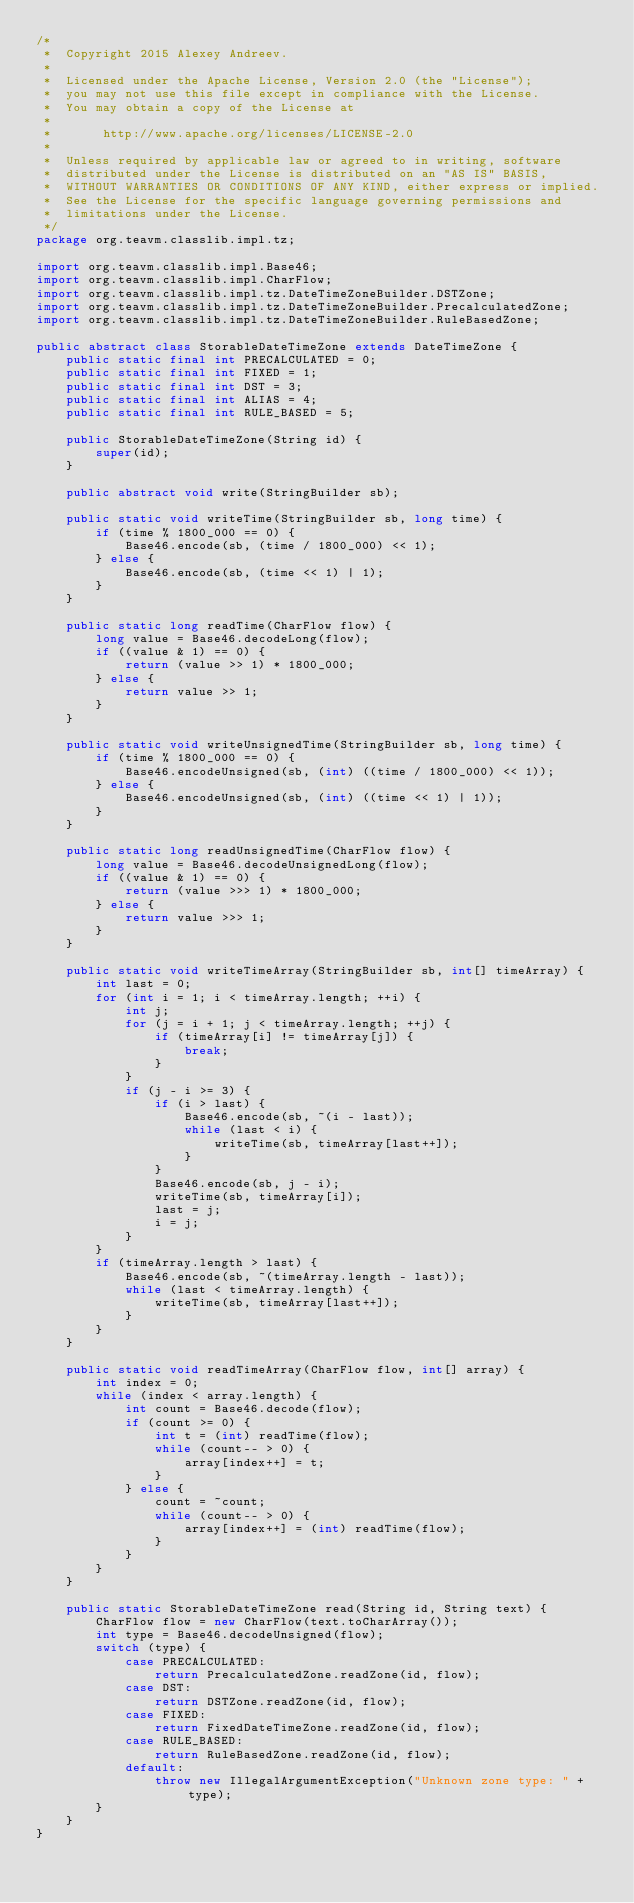<code> <loc_0><loc_0><loc_500><loc_500><_Java_>/*
 *  Copyright 2015 Alexey Andreev.
 *
 *  Licensed under the Apache License, Version 2.0 (the "License");
 *  you may not use this file except in compliance with the License.
 *  You may obtain a copy of the License at
 *
 *       http://www.apache.org/licenses/LICENSE-2.0
 *
 *  Unless required by applicable law or agreed to in writing, software
 *  distributed under the License is distributed on an "AS IS" BASIS,
 *  WITHOUT WARRANTIES OR CONDITIONS OF ANY KIND, either express or implied.
 *  See the License for the specific language governing permissions and
 *  limitations under the License.
 */
package org.teavm.classlib.impl.tz;

import org.teavm.classlib.impl.Base46;
import org.teavm.classlib.impl.CharFlow;
import org.teavm.classlib.impl.tz.DateTimeZoneBuilder.DSTZone;
import org.teavm.classlib.impl.tz.DateTimeZoneBuilder.PrecalculatedZone;
import org.teavm.classlib.impl.tz.DateTimeZoneBuilder.RuleBasedZone;

public abstract class StorableDateTimeZone extends DateTimeZone {
    public static final int PRECALCULATED = 0;
    public static final int FIXED = 1;
    public static final int DST = 3;
    public static final int ALIAS = 4;
    public static final int RULE_BASED = 5;

    public StorableDateTimeZone(String id) {
        super(id);
    }

    public abstract void write(StringBuilder sb);

    public static void writeTime(StringBuilder sb, long time) {
        if (time % 1800_000 == 0) {
            Base46.encode(sb, (time / 1800_000) << 1);
        } else {
            Base46.encode(sb, (time << 1) | 1);
        }
    }

    public static long readTime(CharFlow flow) {
        long value = Base46.decodeLong(flow);
        if ((value & 1) == 0) {
            return (value >> 1) * 1800_000;
        } else {
            return value >> 1;
        }
    }

    public static void writeUnsignedTime(StringBuilder sb, long time) {
        if (time % 1800_000 == 0) {
            Base46.encodeUnsigned(sb, (int) ((time / 1800_000) << 1));
        } else {
            Base46.encodeUnsigned(sb, (int) ((time << 1) | 1));
        }
    }

    public static long readUnsignedTime(CharFlow flow) {
        long value = Base46.decodeUnsignedLong(flow);
        if ((value & 1) == 0) {
            return (value >>> 1) * 1800_000;
        } else {
            return value >>> 1;
        }
    }

    public static void writeTimeArray(StringBuilder sb, int[] timeArray) {
        int last = 0;
        for (int i = 1; i < timeArray.length; ++i) {
            int j;
            for (j = i + 1; j < timeArray.length; ++j) {
                if (timeArray[i] != timeArray[j]) {
                    break;
                }
            }
            if (j - i >= 3) {
                if (i > last) {
                    Base46.encode(sb, ~(i - last));
                    while (last < i) {
                        writeTime(sb, timeArray[last++]);
                    }
                }
                Base46.encode(sb, j - i);
                writeTime(sb, timeArray[i]);
                last = j;
                i = j;
            }
        }
        if (timeArray.length > last) {
            Base46.encode(sb, ~(timeArray.length - last));
            while (last < timeArray.length) {
                writeTime(sb, timeArray[last++]);
            }
        }
    }

    public static void readTimeArray(CharFlow flow, int[] array) {
        int index = 0;
        while (index < array.length) {
            int count = Base46.decode(flow);
            if (count >= 0) {
                int t = (int) readTime(flow);
                while (count-- > 0) {
                    array[index++] = t;
                }
            } else {
                count = ~count;
                while (count-- > 0) {
                    array[index++] = (int) readTime(flow);
                }
            }
        }
    }

    public static StorableDateTimeZone read(String id, String text) {
        CharFlow flow = new CharFlow(text.toCharArray());
        int type = Base46.decodeUnsigned(flow);
        switch (type) {
            case PRECALCULATED:
                return PrecalculatedZone.readZone(id, flow);
            case DST:
                return DSTZone.readZone(id, flow);
            case FIXED:
                return FixedDateTimeZone.readZone(id, flow);
            case RULE_BASED:
                return RuleBasedZone.readZone(id, flow);
            default:
                throw new IllegalArgumentException("Unknown zone type: " + type);
        }
    }
}
</code> 